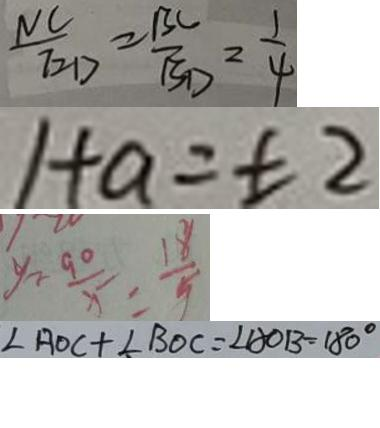<formula> <loc_0><loc_0><loc_500><loc_500>\frac { N C } { E D } = \frac { B C } { B D } = \frac { 1 } { 4 } 
 1 + a = \pm 2 
 y - \frac { 9 0 } { x } = \frac { 1 8 } { 5 } 
 \angle A O C + \angle B O C = \angle A O B = 1 8 0 ^ { \circ }</formula> 